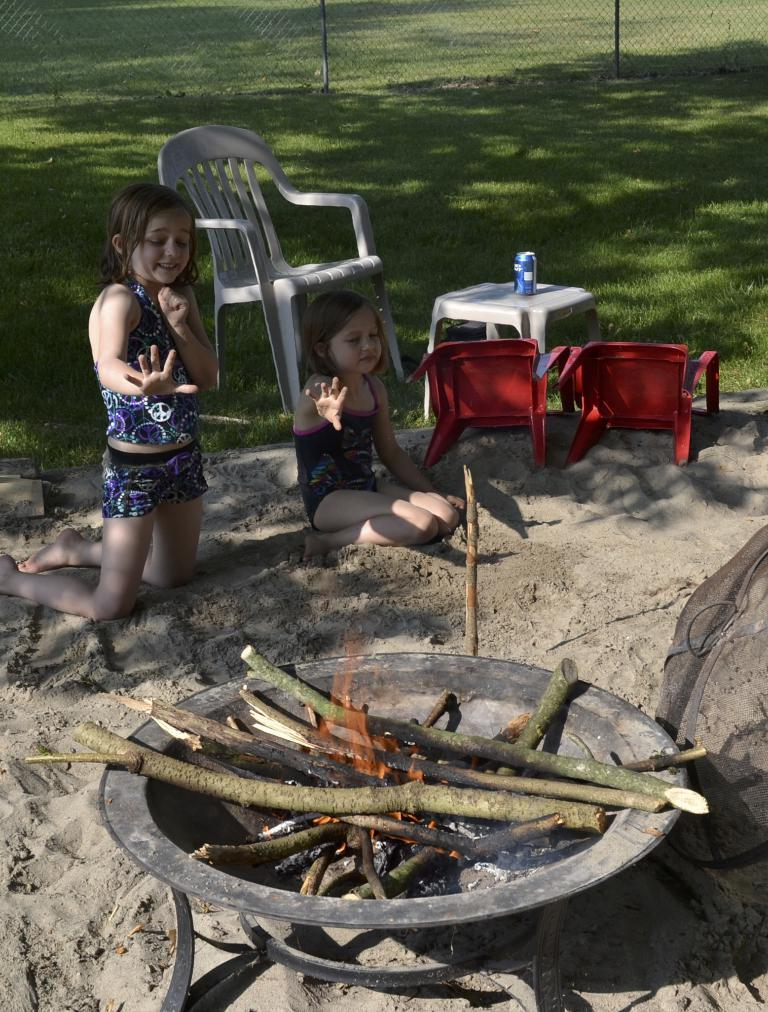What is the main feature in the image? There is a campfire in the image. Who is present near the campfire? Children are sitting on the sand near the campfire. What type of seating is available in the image? There are chairs in the image. What can be seen next to the children? A beverage bottle is visible. What is the texture of the ground in the image? The ground is visible and appears to be sandy. What type of stone is being used for the selection process in the image? There is no mention of a selection process or any stones present in the image. 